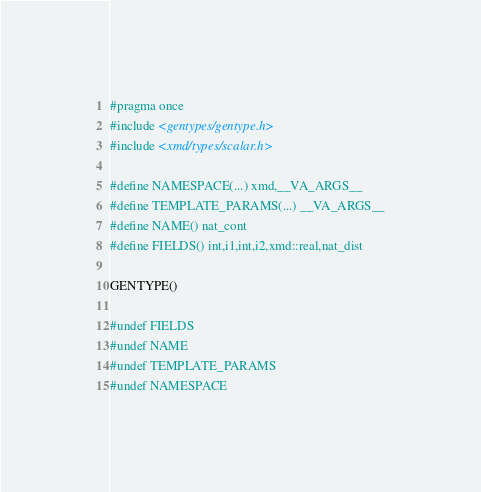Convert code to text. <code><loc_0><loc_0><loc_500><loc_500><_C_>#pragma once
#include <gentypes/gentype.h>
#include <xmd/types/scalar.h>

#define NAMESPACE(...) xmd,__VA_ARGS__
#define TEMPLATE_PARAMS(...) __VA_ARGS__
#define NAME() nat_cont
#define FIELDS() int,i1,int,i2,xmd::real,nat_dist

GENTYPE()

#undef FIELDS
#undef NAME
#undef TEMPLATE_PARAMS
#undef NAMESPACE</code> 